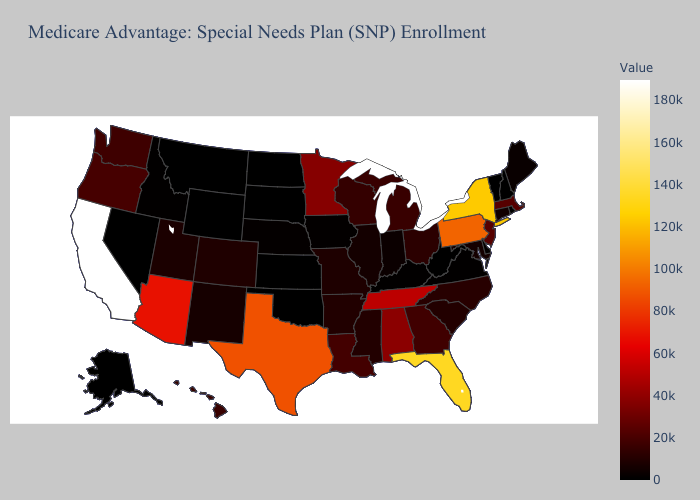Does Arizona have the highest value in the West?
Be succinct. No. Which states have the highest value in the USA?
Keep it brief. California. Which states hav the highest value in the South?
Be succinct. Florida. Is the legend a continuous bar?
Quick response, please. Yes. Does Maryland have the lowest value in the South?
Short answer required. No. Does California have the highest value in the USA?
Write a very short answer. Yes. 